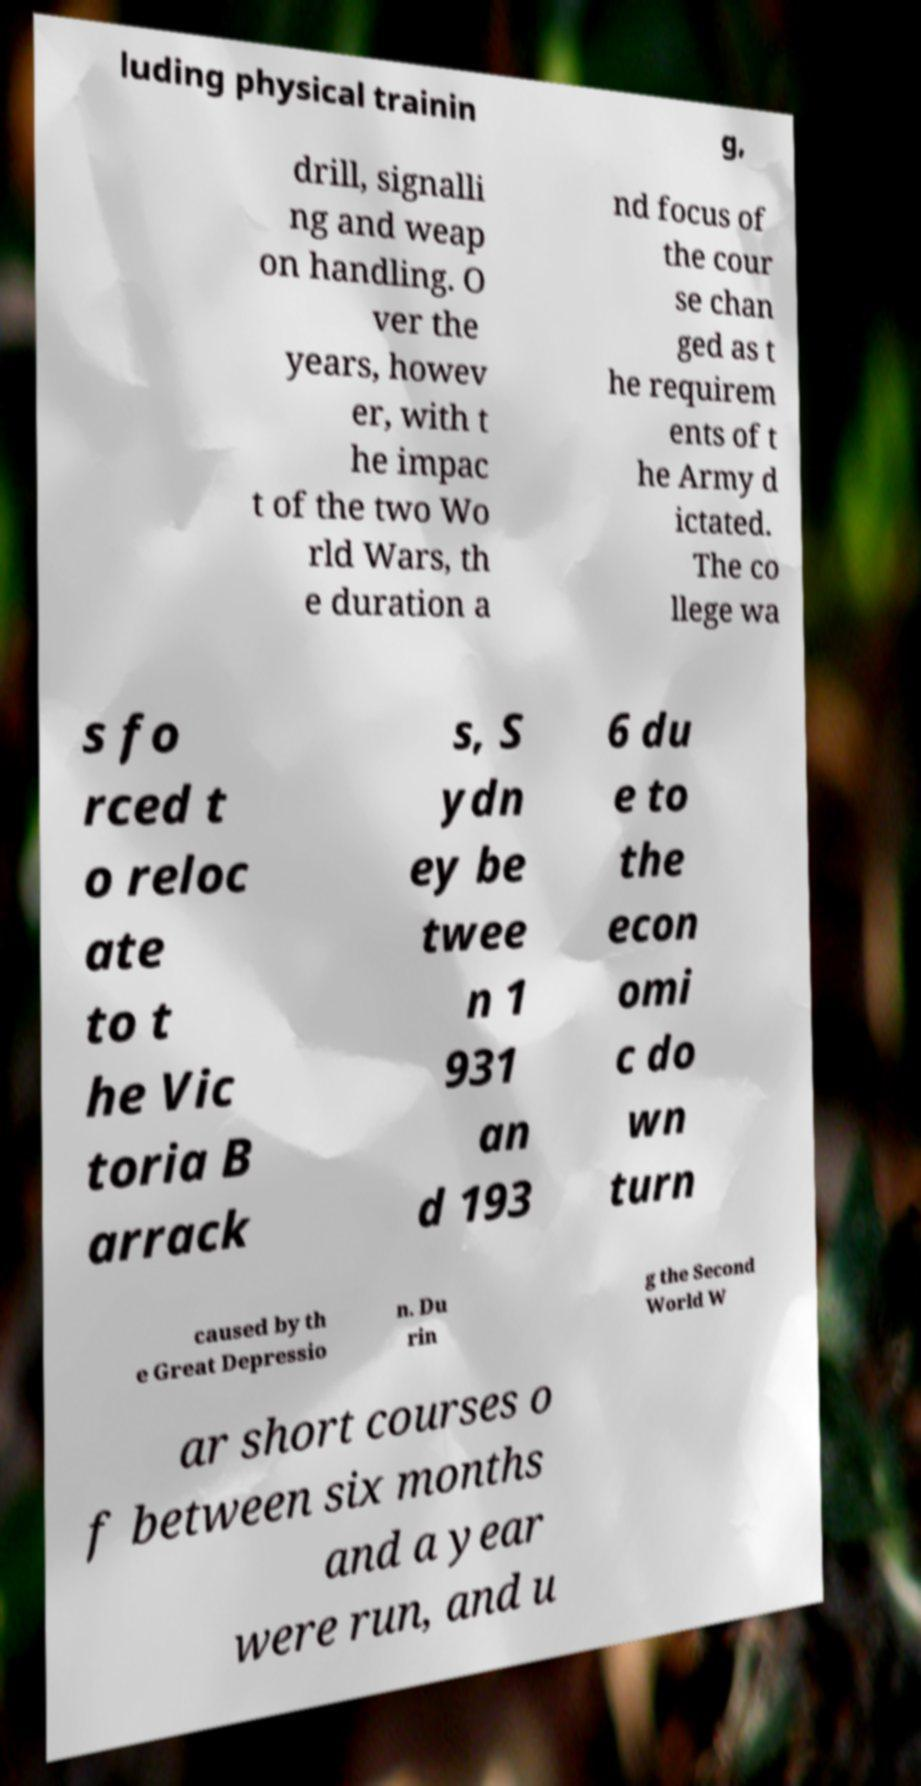Can you accurately transcribe the text from the provided image for me? luding physical trainin g, drill, signalli ng and weap on handling. O ver the years, howev er, with t he impac t of the two Wo rld Wars, th e duration a nd focus of the cour se chan ged as t he requirem ents of t he Army d ictated. The co llege wa s fo rced t o reloc ate to t he Vic toria B arrack s, S ydn ey be twee n 1 931 an d 193 6 du e to the econ omi c do wn turn caused by th e Great Depressio n. Du rin g the Second World W ar short courses o f between six months and a year were run, and u 